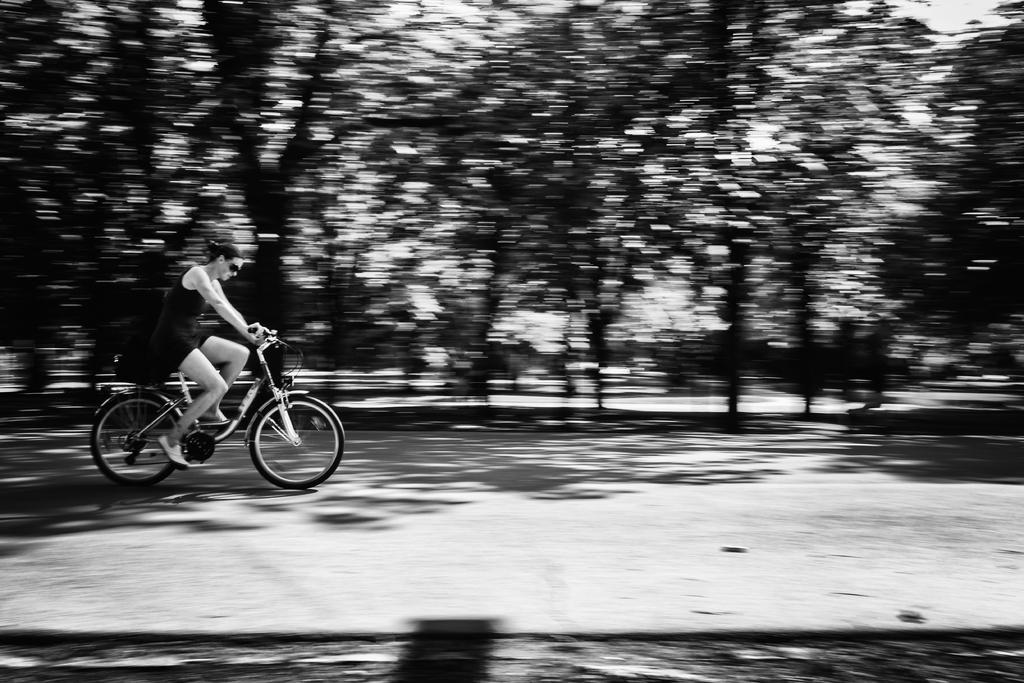Who is the main subject in the image? There is a woman in the image. What is the woman doing in the image? The woman is riding a bicycle. Where is the bicycle located? The bicycle is on a road. What type of hose can be seen attached to the woman's leg in the image? There is no hose present in the image; the woman is simply riding a bicycle on a road. 